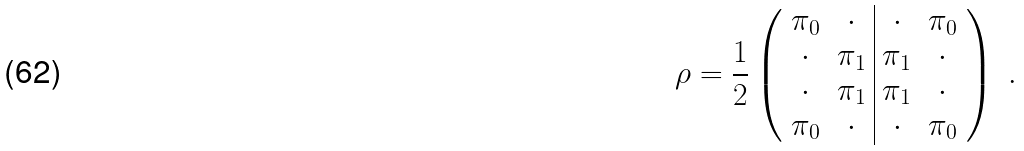<formula> <loc_0><loc_0><loc_500><loc_500>\rho = \frac { 1 } { 2 } \left ( \begin{array} { c c | c c } \pi _ { 0 } & \cdot & \cdot & \pi _ { 0 } \\ \cdot & \pi _ { 1 } & \pi _ { 1 } & \cdot \\ \cdot & \pi _ { 1 } & \pi _ { 1 } & \cdot \\ \pi _ { 0 } & \cdot & \cdot & \pi _ { 0 } \end{array} \right ) \ .</formula> 